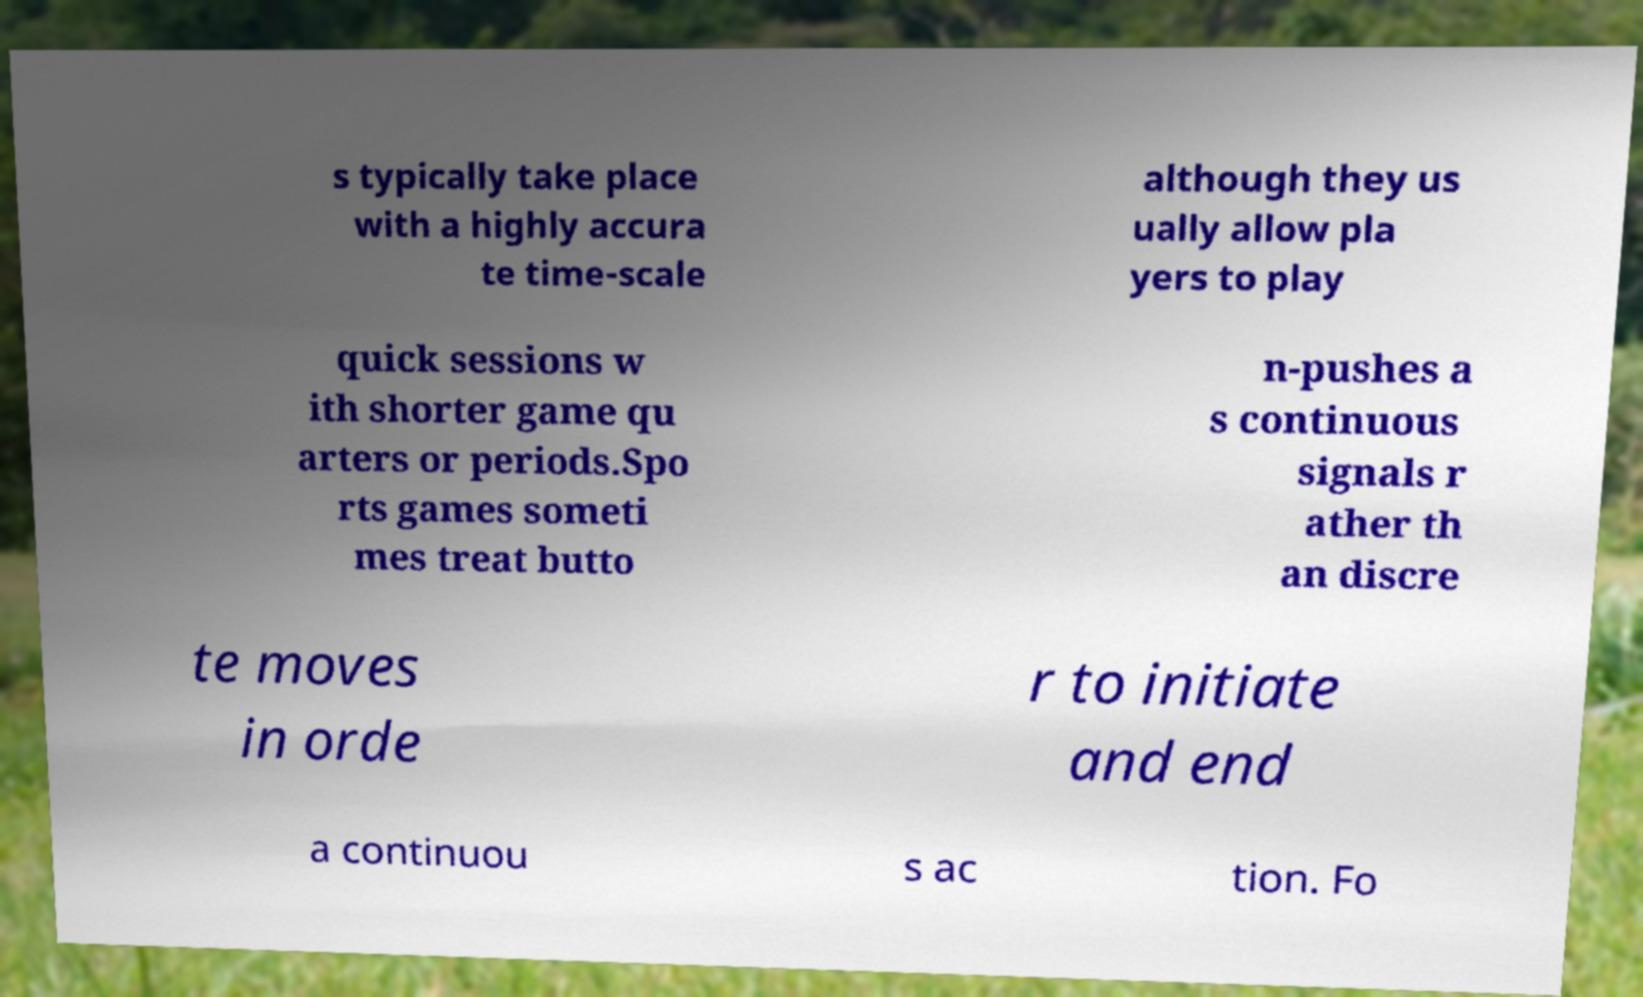Can you read and provide the text displayed in the image?This photo seems to have some interesting text. Can you extract and type it out for me? s typically take place with a highly accura te time-scale although they us ually allow pla yers to play quick sessions w ith shorter game qu arters or periods.Spo rts games someti mes treat butto n-pushes a s continuous signals r ather th an discre te moves in orde r to initiate and end a continuou s ac tion. Fo 